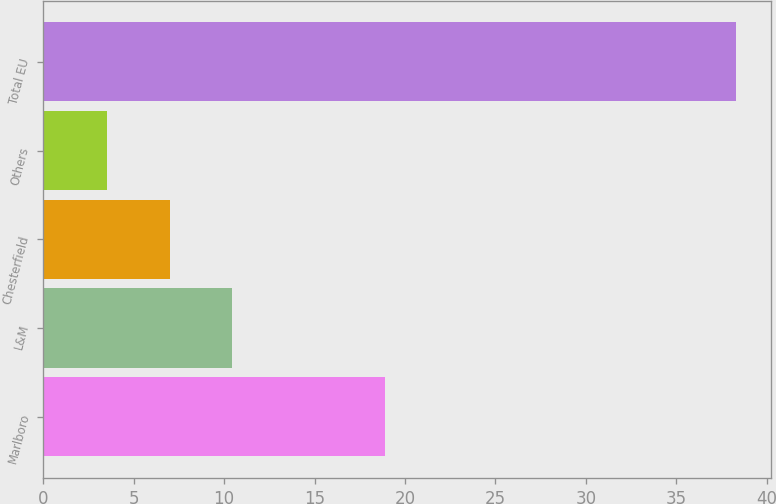Convert chart to OTSL. <chart><loc_0><loc_0><loc_500><loc_500><bar_chart><fcel>Marlboro<fcel>L&M<fcel>Chesterfield<fcel>Others<fcel>Total EU<nl><fcel>18.9<fcel>10.46<fcel>6.98<fcel>3.5<fcel>38.3<nl></chart> 